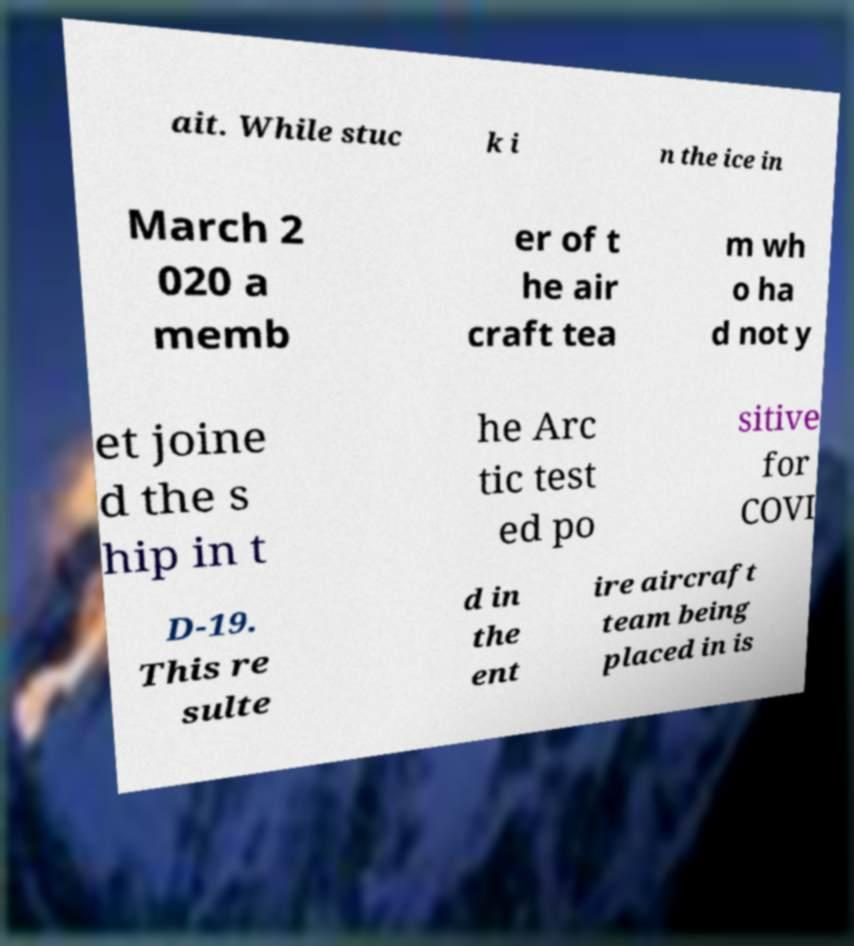There's text embedded in this image that I need extracted. Can you transcribe it verbatim? ait. While stuc k i n the ice in March 2 020 a memb er of t he air craft tea m wh o ha d not y et joine d the s hip in t he Arc tic test ed po sitive for COVI D-19. This re sulte d in the ent ire aircraft team being placed in is 